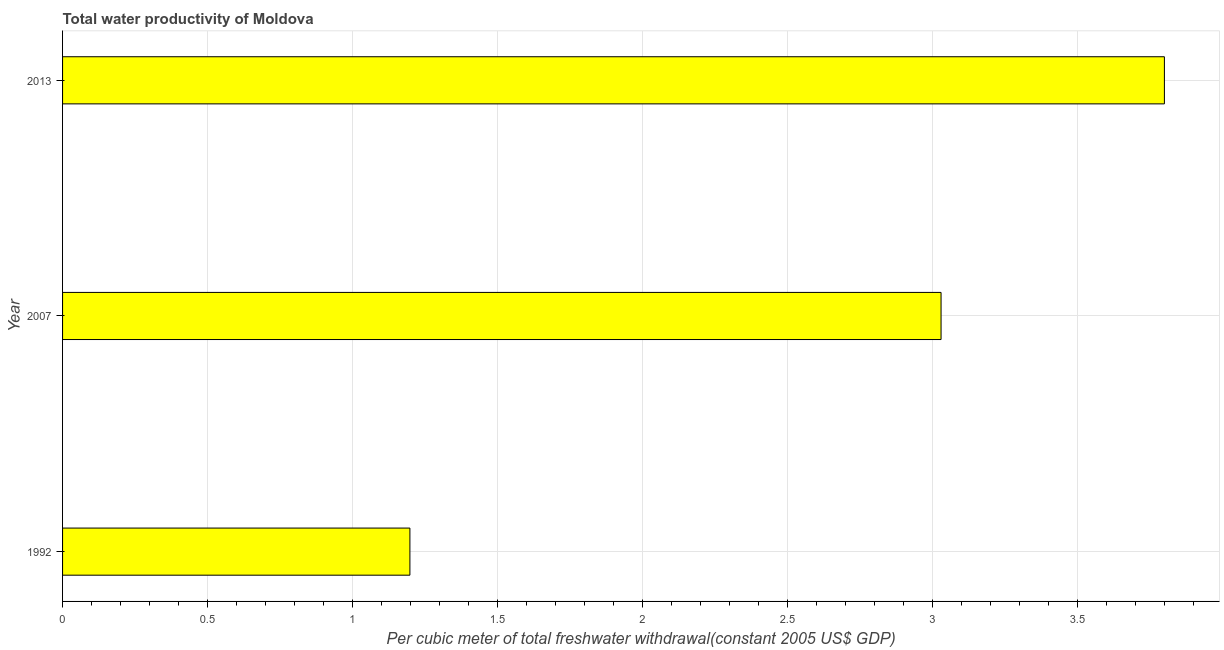Does the graph contain any zero values?
Your response must be concise. No. Does the graph contain grids?
Offer a terse response. Yes. What is the title of the graph?
Offer a very short reply. Total water productivity of Moldova. What is the label or title of the X-axis?
Provide a succinct answer. Per cubic meter of total freshwater withdrawal(constant 2005 US$ GDP). What is the total water productivity in 1992?
Provide a short and direct response. 1.2. Across all years, what is the maximum total water productivity?
Your response must be concise. 3.8. Across all years, what is the minimum total water productivity?
Your response must be concise. 1.2. In which year was the total water productivity maximum?
Your answer should be compact. 2013. What is the sum of the total water productivity?
Provide a short and direct response. 8.03. What is the difference between the total water productivity in 1992 and 2013?
Make the answer very short. -2.6. What is the average total water productivity per year?
Provide a short and direct response. 2.68. What is the median total water productivity?
Offer a terse response. 3.03. Do a majority of the years between 2007 and 2013 (inclusive) have total water productivity greater than 0.8 US$?
Your answer should be compact. Yes. What is the ratio of the total water productivity in 1992 to that in 2007?
Give a very brief answer. 0.4. Is the total water productivity in 1992 less than that in 2013?
Offer a terse response. Yes. What is the difference between the highest and the second highest total water productivity?
Make the answer very short. 0.77. How many years are there in the graph?
Offer a terse response. 3. Are the values on the major ticks of X-axis written in scientific E-notation?
Ensure brevity in your answer.  No. What is the Per cubic meter of total freshwater withdrawal(constant 2005 US$ GDP) in 1992?
Your answer should be compact. 1.2. What is the Per cubic meter of total freshwater withdrawal(constant 2005 US$ GDP) in 2007?
Offer a very short reply. 3.03. What is the Per cubic meter of total freshwater withdrawal(constant 2005 US$ GDP) in 2013?
Your answer should be very brief. 3.8. What is the difference between the Per cubic meter of total freshwater withdrawal(constant 2005 US$ GDP) in 1992 and 2007?
Your response must be concise. -1.83. What is the difference between the Per cubic meter of total freshwater withdrawal(constant 2005 US$ GDP) in 1992 and 2013?
Make the answer very short. -2.6. What is the difference between the Per cubic meter of total freshwater withdrawal(constant 2005 US$ GDP) in 2007 and 2013?
Make the answer very short. -0.77. What is the ratio of the Per cubic meter of total freshwater withdrawal(constant 2005 US$ GDP) in 1992 to that in 2007?
Give a very brief answer. 0.4. What is the ratio of the Per cubic meter of total freshwater withdrawal(constant 2005 US$ GDP) in 1992 to that in 2013?
Make the answer very short. 0.32. What is the ratio of the Per cubic meter of total freshwater withdrawal(constant 2005 US$ GDP) in 2007 to that in 2013?
Give a very brief answer. 0.8. 